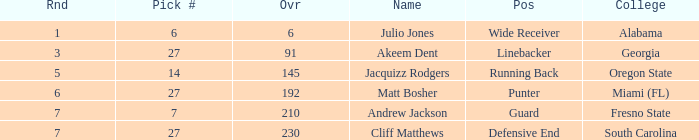Which name had more than 5 rounds and was a defensive end? Cliff Matthews. 